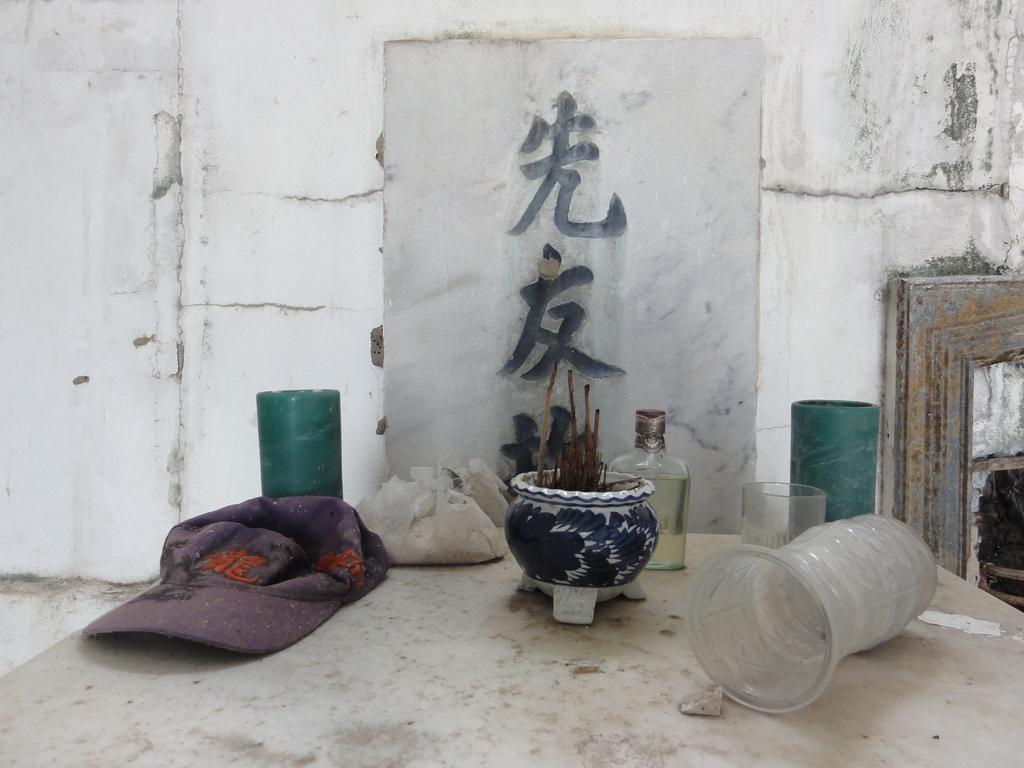What piece of furniture is visible in the image? There is a table in the image. Where is the table located in relation to the image? The table is located towards the bottom of the image. What can be found on the table? There are objects on the table. What is visible in the background of the image? There is a wall in the background of the image. What is written or depicted on the wall? There is text on the wall. What type of steel is used to construct the grass in the image? There is no steel or grass present in the image. 